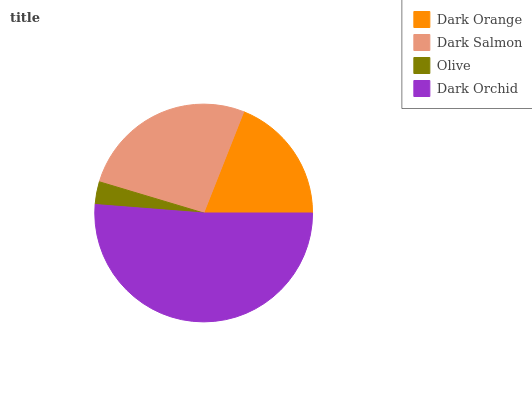Is Olive the minimum?
Answer yes or no. Yes. Is Dark Orchid the maximum?
Answer yes or no. Yes. Is Dark Salmon the minimum?
Answer yes or no. No. Is Dark Salmon the maximum?
Answer yes or no. No. Is Dark Salmon greater than Dark Orange?
Answer yes or no. Yes. Is Dark Orange less than Dark Salmon?
Answer yes or no. Yes. Is Dark Orange greater than Dark Salmon?
Answer yes or no. No. Is Dark Salmon less than Dark Orange?
Answer yes or no. No. Is Dark Salmon the high median?
Answer yes or no. Yes. Is Dark Orange the low median?
Answer yes or no. Yes. Is Olive the high median?
Answer yes or no. No. Is Dark Orchid the low median?
Answer yes or no. No. 